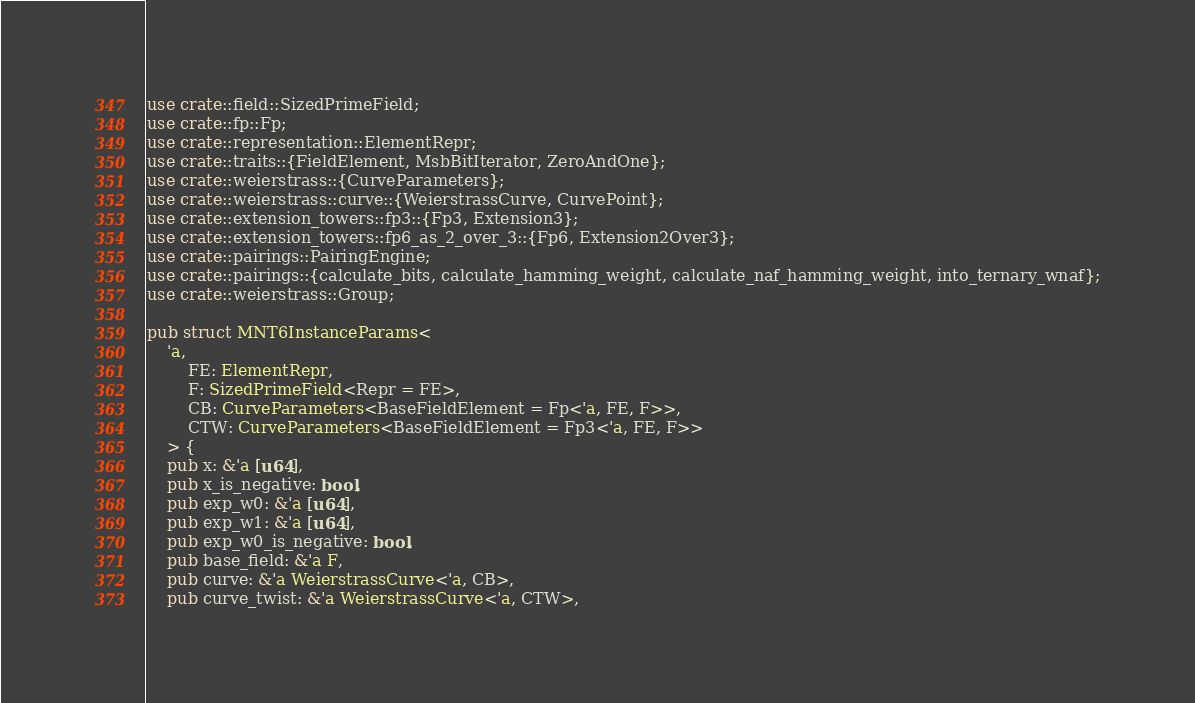<code> <loc_0><loc_0><loc_500><loc_500><_Rust_>use crate::field::SizedPrimeField;
use crate::fp::Fp;
use crate::representation::ElementRepr;
use crate::traits::{FieldElement, MsbBitIterator, ZeroAndOne};
use crate::weierstrass::{CurveParameters};
use crate::weierstrass::curve::{WeierstrassCurve, CurvePoint};
use crate::extension_towers::fp3::{Fp3, Extension3};
use crate::extension_towers::fp6_as_2_over_3::{Fp6, Extension2Over3};
use crate::pairings::PairingEngine;
use crate::pairings::{calculate_bits, calculate_hamming_weight, calculate_naf_hamming_weight, into_ternary_wnaf};
use crate::weierstrass::Group;

pub struct MNT6InstanceParams<
    'a, 
        FE: ElementRepr, 
        F: SizedPrimeField<Repr = FE>, 
        CB: CurveParameters<BaseFieldElement = Fp<'a, FE, F>>,
        CTW: CurveParameters<BaseFieldElement = Fp3<'a, FE, F>>
    > {
    pub x: &'a [u64],
    pub x_is_negative: bool,
    pub exp_w0: &'a [u64],
    pub exp_w1: &'a [u64],
    pub exp_w0_is_negative: bool,
    pub base_field: &'a F,
    pub curve: &'a WeierstrassCurve<'a, CB>,
    pub curve_twist: &'a WeierstrassCurve<'a, CTW>,</code> 